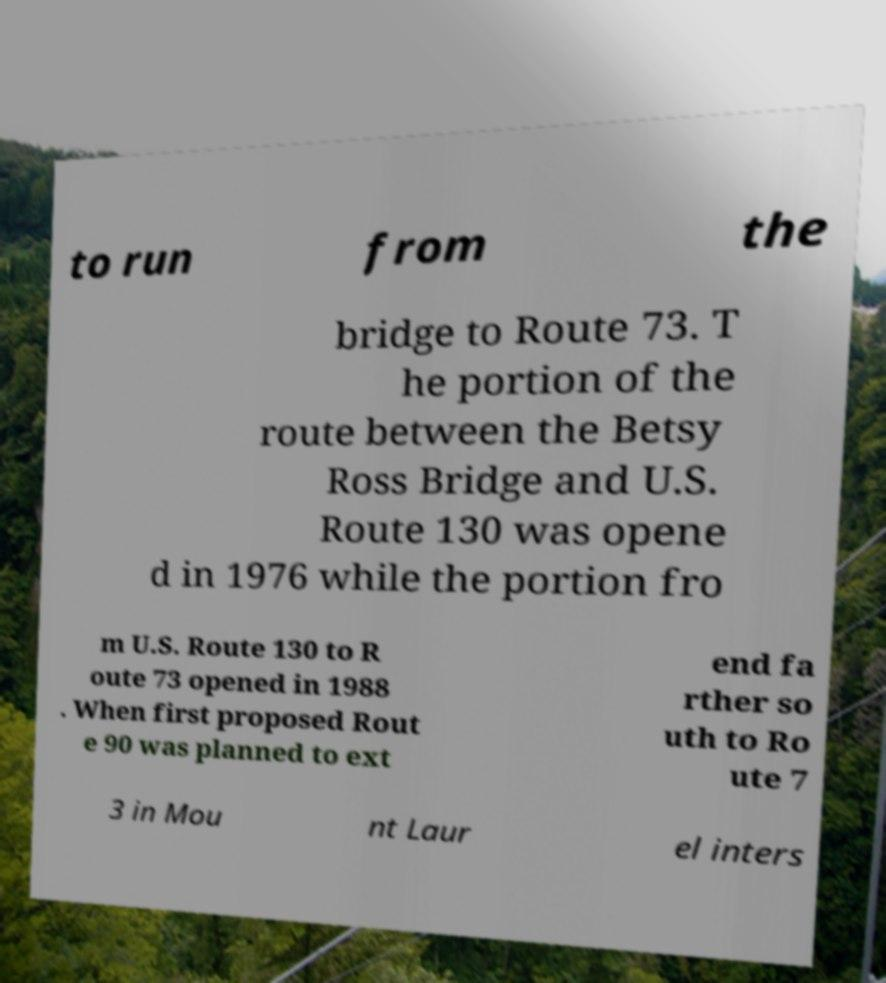Can you read and provide the text displayed in the image?This photo seems to have some interesting text. Can you extract and type it out for me? to run from the bridge to Route 73. T he portion of the route between the Betsy Ross Bridge and U.S. Route 130 was opene d in 1976 while the portion fro m U.S. Route 130 to R oute 73 opened in 1988 . When first proposed Rout e 90 was planned to ext end fa rther so uth to Ro ute 7 3 in Mou nt Laur el inters 